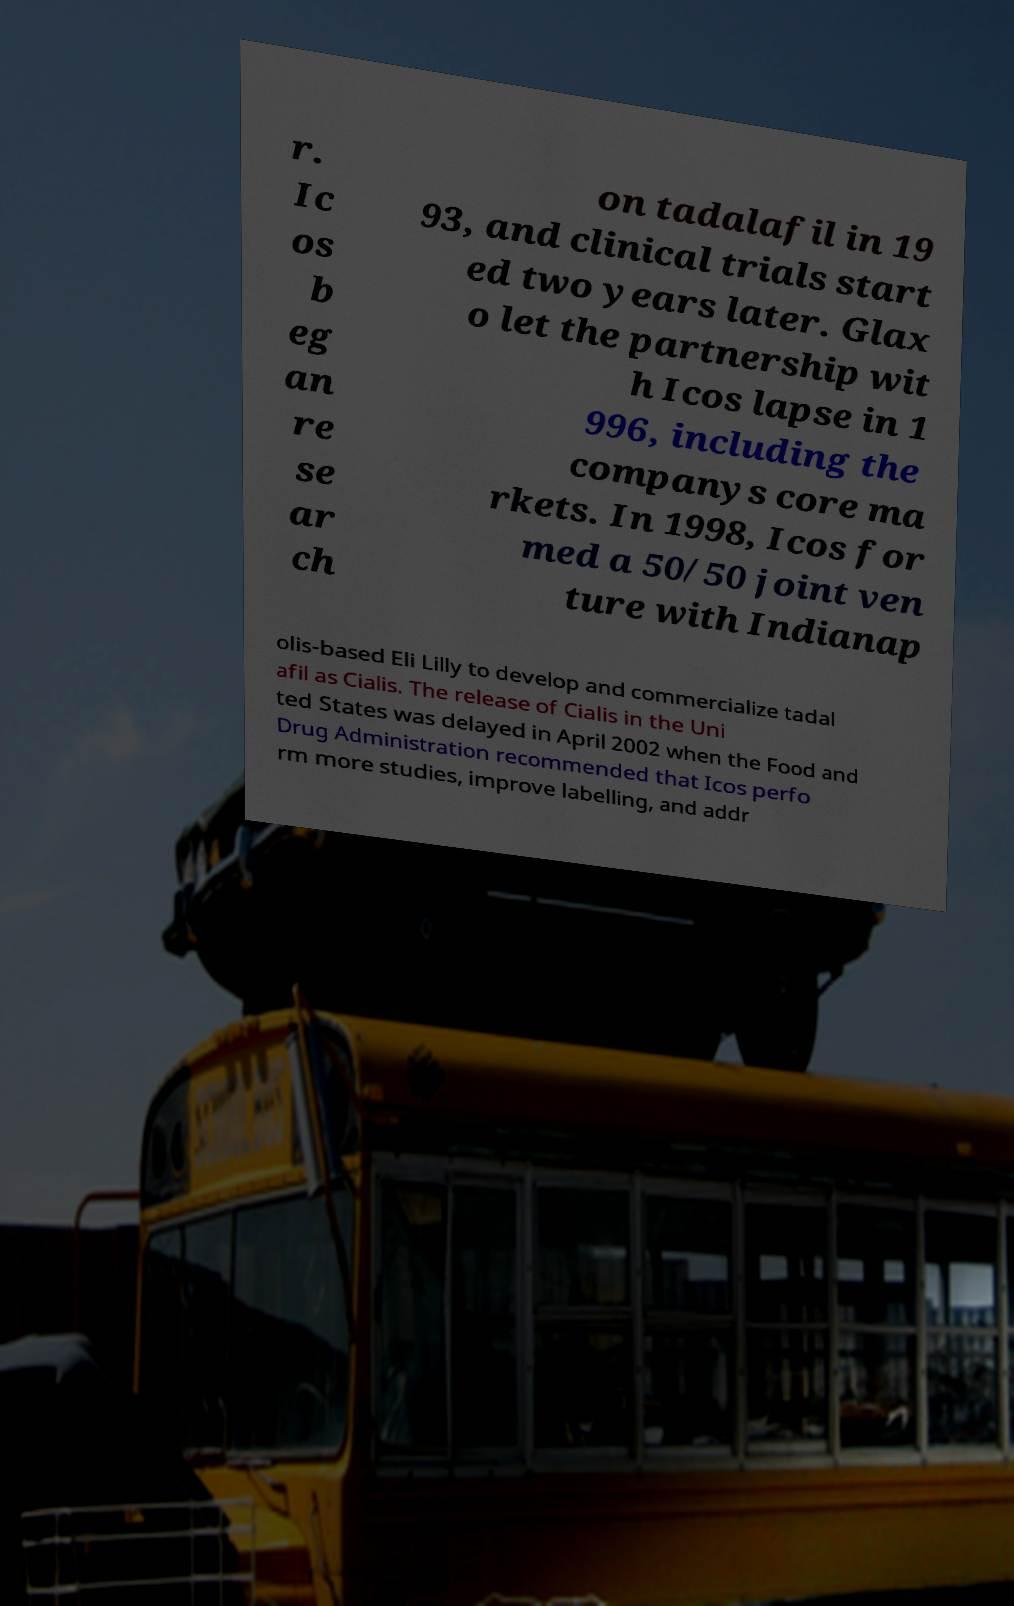What messages or text are displayed in this image? I need them in a readable, typed format. r. Ic os b eg an re se ar ch on tadalafil in 19 93, and clinical trials start ed two years later. Glax o let the partnership wit h Icos lapse in 1 996, including the companys core ma rkets. In 1998, Icos for med a 50/50 joint ven ture with Indianap olis-based Eli Lilly to develop and commercialize tadal afil as Cialis. The release of Cialis in the Uni ted States was delayed in April 2002 when the Food and Drug Administration recommended that Icos perfo rm more studies, improve labelling, and addr 